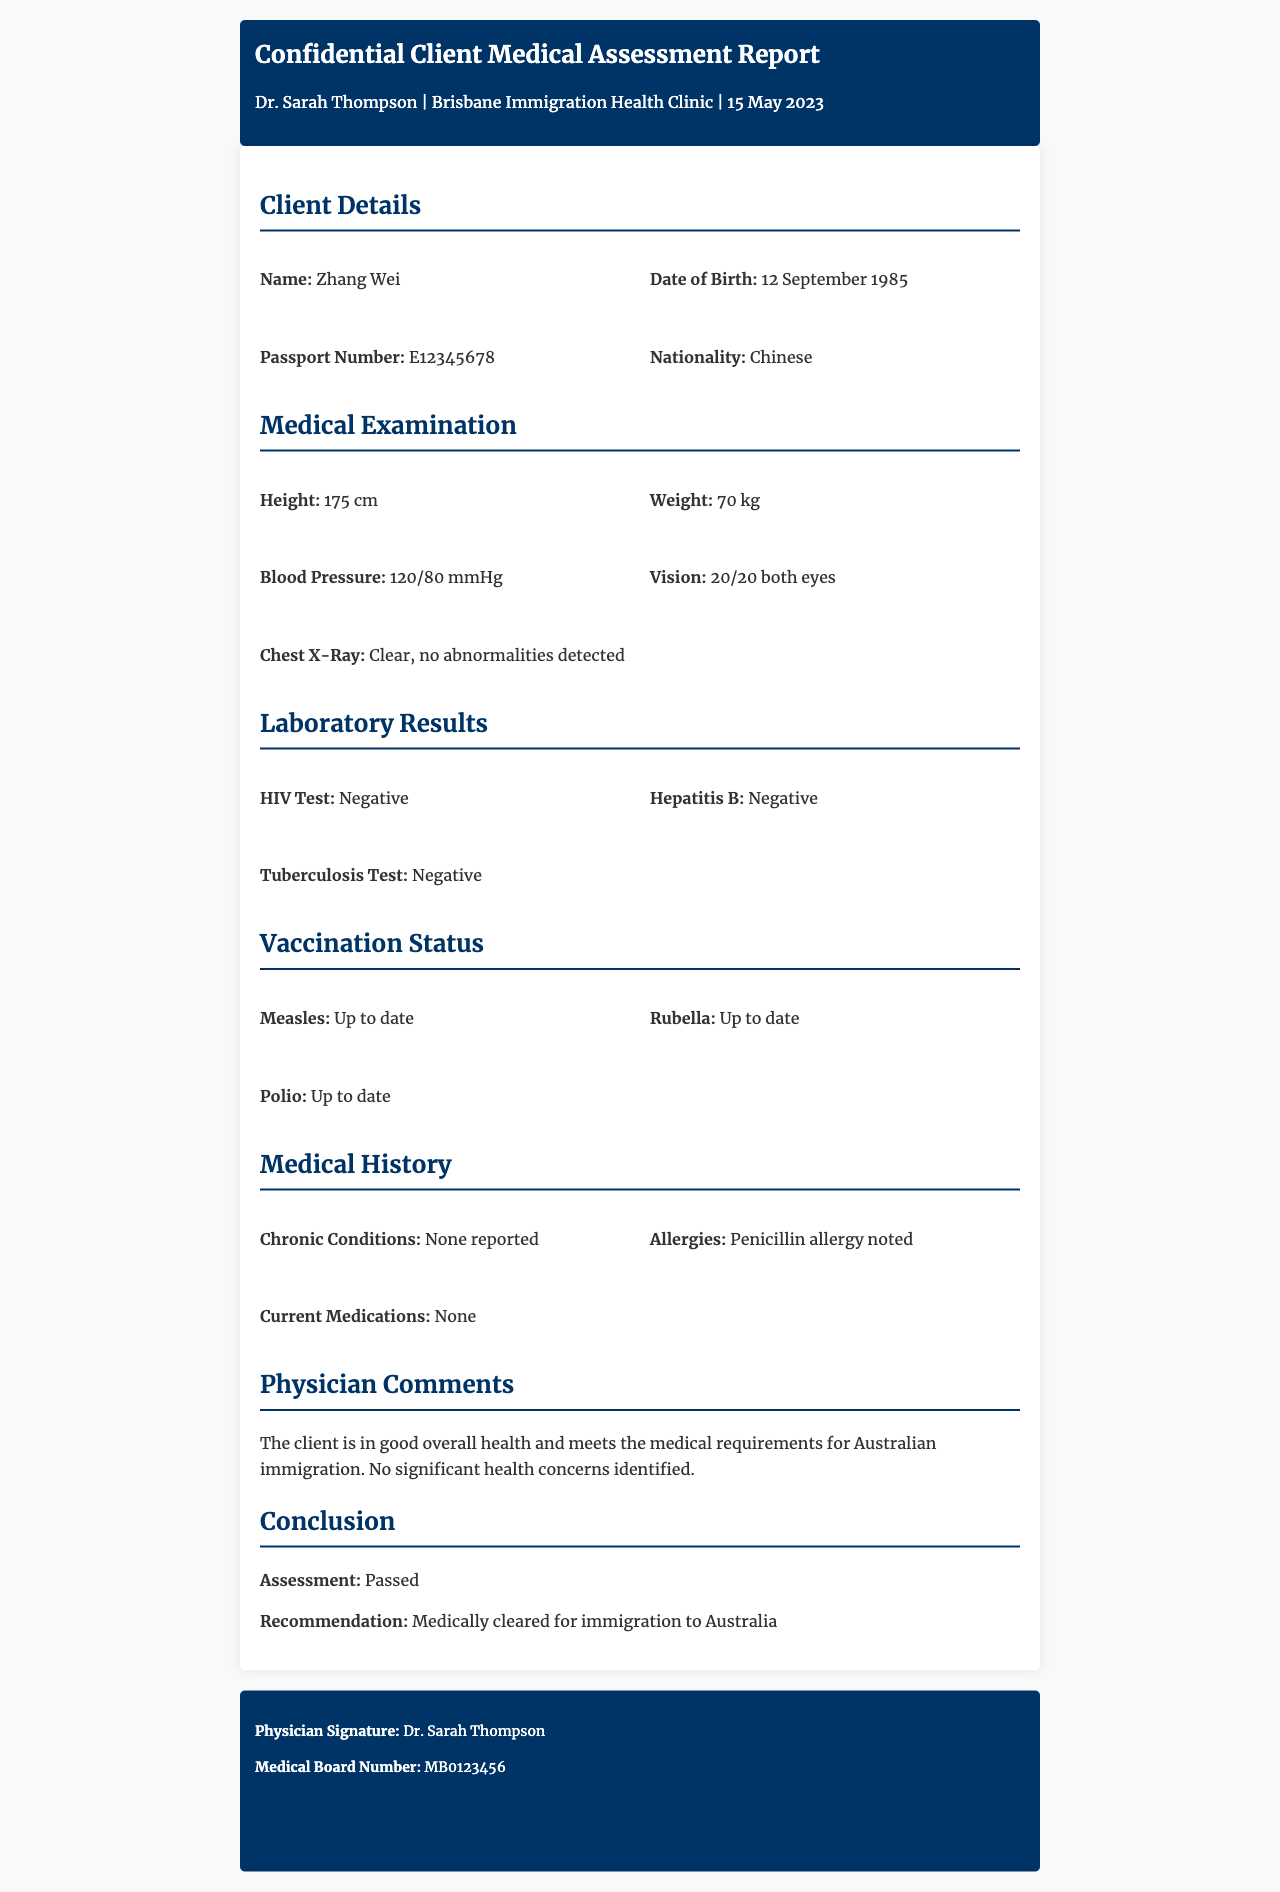What is the name of the client? The document states the client's name as Zhang Wei in the Client Details section.
Answer: Zhang Wei What is the date of birth of the client? According to the document, the client's date of birth is provided in the Client Details section.
Answer: 12 September 1985 What is the client's nationality? The document specifies the client's nationality in the Client Details section, which is key for immigration purposes.
Answer: Chinese What were the results of the HIV test? The HIV test result is clearly stated in the Laboratory Results section of the document.
Answer: Negative What is the physician's recommendation for the client? The recommendation is explicitly mentioned in the Conclusion section of the document and indicates the client's status for immigration.
Answer: Medically cleared for immigration to Australia What is noted about the client's allergies? The document highlights the specifics about the client's allergies in the Medical History section, making it relevant for health assessments.
Answer: Penicillin allergy noted What was the client's chest X-Ray result? The result of the chest X-Ray is mentioned in the Medical Examination section, indicating the client's health status.
Answer: Clear, no abnormalities detected Who conducted the medical assessment? The document identifies the physician who performed the assessment, which is important for validating the report.
Answer: Dr. Sarah Thompson What is the medical board number of the physician? The medical board number is listed in the footer of the document, which can be crucial for professional verification.
Answer: MB0123456 